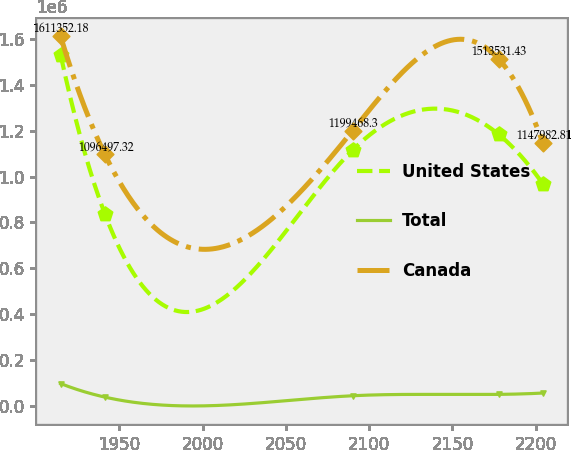Convert chart. <chart><loc_0><loc_0><loc_500><loc_500><line_chart><ecel><fcel>United States<fcel>Total<fcel>Canada<nl><fcel>1914.84<fcel>1.53135e+06<fcel>96421.4<fcel>1.61135e+06<nl><fcel>1941.4<fcel>836596<fcel>37295.4<fcel>1.0965e+06<nl><fcel>2090.03<fcel>1.11487e+06<fcel>43208<fcel>1.19947e+06<nl><fcel>2177.64<fcel>1.18434e+06<fcel>49120.6<fcel>1.51353e+06<nl><fcel>2204.2<fcel>968399<fcel>55033.2<fcel>1.14798e+06<nl></chart> 